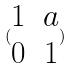<formula> <loc_0><loc_0><loc_500><loc_500>( \begin{matrix} 1 & a \\ 0 & 1 \end{matrix} )</formula> 